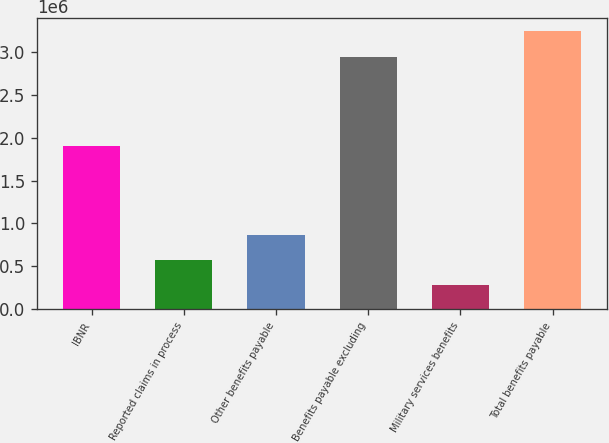Convert chart to OTSL. <chart><loc_0><loc_0><loc_500><loc_500><bar_chart><fcel>IBNR<fcel>Reported claims in process<fcel>Other benefits payable<fcel>Benefits payable excluding<fcel>Military services benefits<fcel>Total benefits payable<nl><fcel>1.9027e+06<fcel>573533<fcel>867871<fcel>2.94338e+06<fcel>279195<fcel>3.23772e+06<nl></chart> 